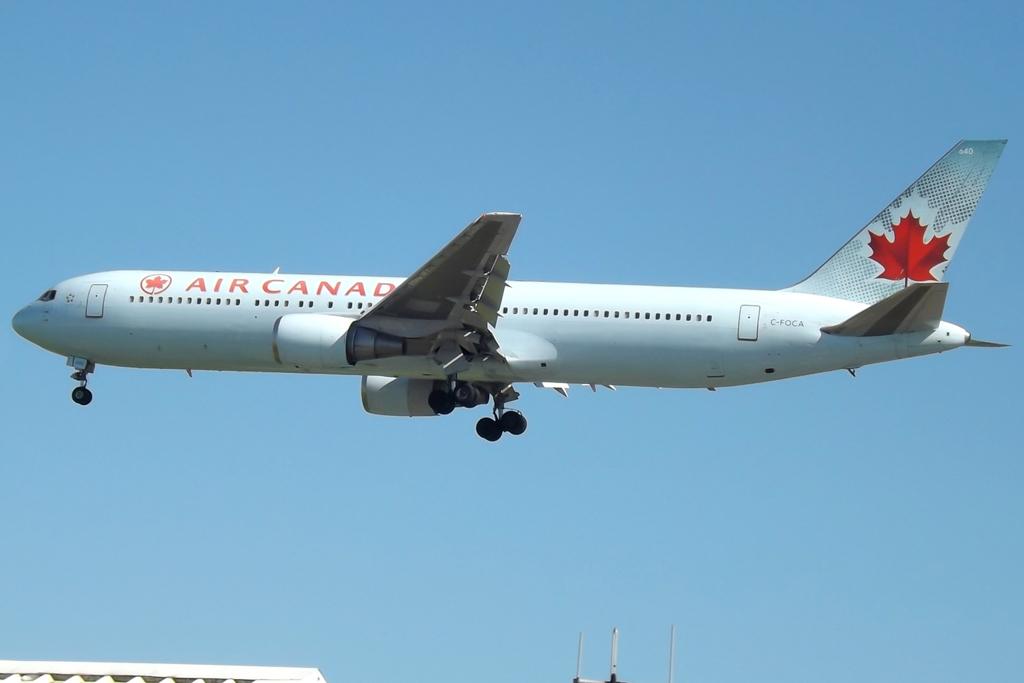What is the name of the airline?
Offer a very short reply. Air canada. 